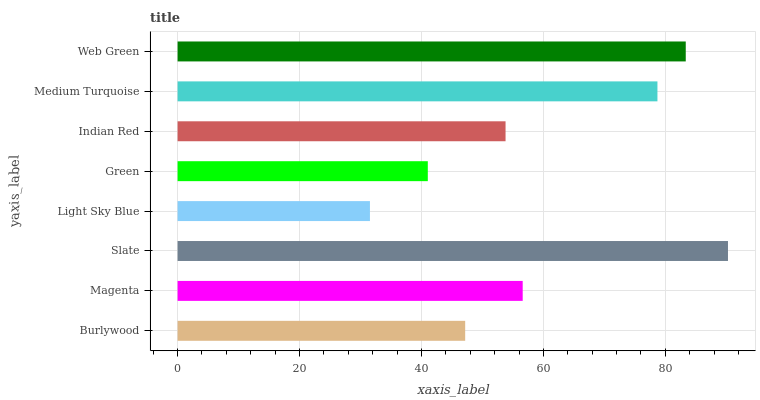Is Light Sky Blue the minimum?
Answer yes or no. Yes. Is Slate the maximum?
Answer yes or no. Yes. Is Magenta the minimum?
Answer yes or no. No. Is Magenta the maximum?
Answer yes or no. No. Is Magenta greater than Burlywood?
Answer yes or no. Yes. Is Burlywood less than Magenta?
Answer yes or no. Yes. Is Burlywood greater than Magenta?
Answer yes or no. No. Is Magenta less than Burlywood?
Answer yes or no. No. Is Magenta the high median?
Answer yes or no. Yes. Is Indian Red the low median?
Answer yes or no. Yes. Is Burlywood the high median?
Answer yes or no. No. Is Web Green the low median?
Answer yes or no. No. 